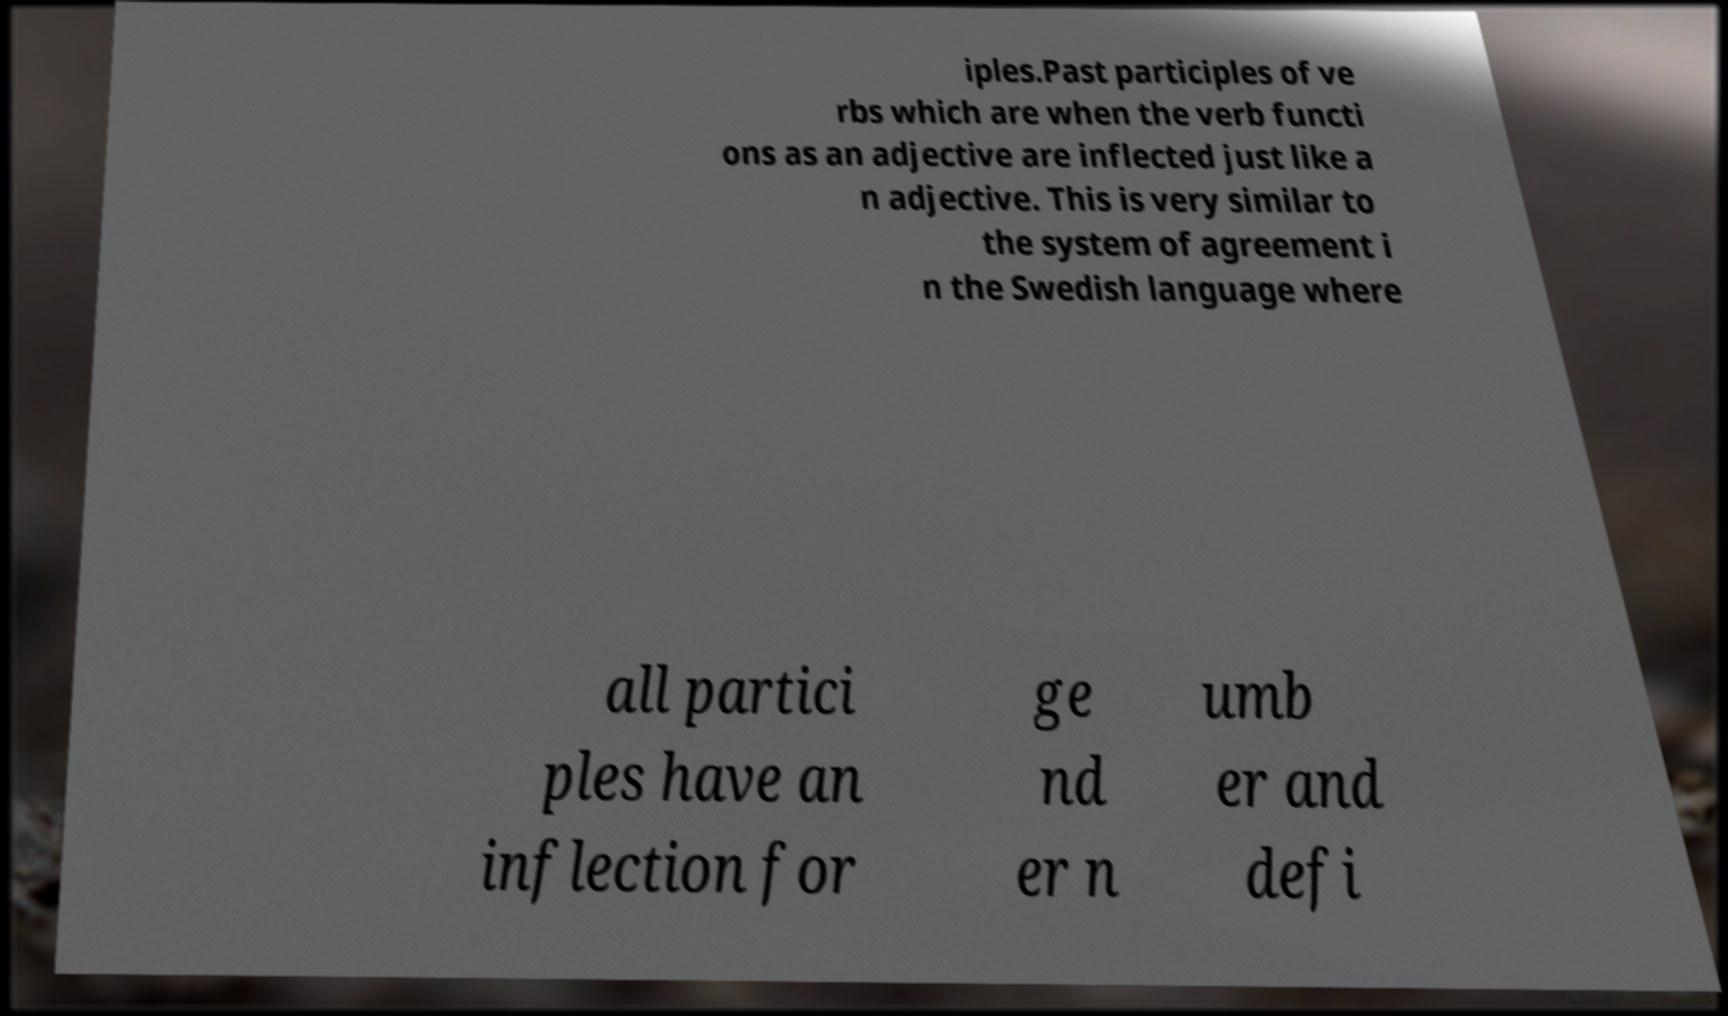Could you extract and type out the text from this image? iples.Past participles of ve rbs which are when the verb functi ons as an adjective are inflected just like a n adjective. This is very similar to the system of agreement i n the Swedish language where all partici ples have an inflection for ge nd er n umb er and defi 